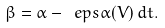<formula> <loc_0><loc_0><loc_500><loc_500>\beta = \alpha - \ e p s \alpha ( V ) \, d t .</formula> 